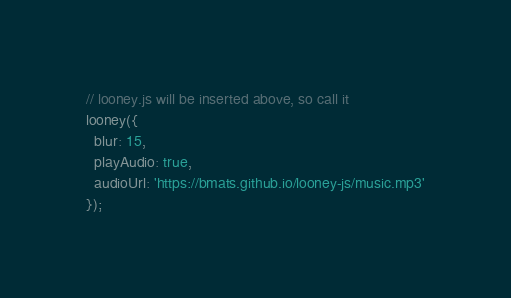<code> <loc_0><loc_0><loc_500><loc_500><_JavaScript_>// looney.js will be inserted above, so call it
looney({
  blur: 15,
  playAudio: true,
  audioUrl: 'https://bmats.github.io/looney-js/music.mp3'
});
</code> 